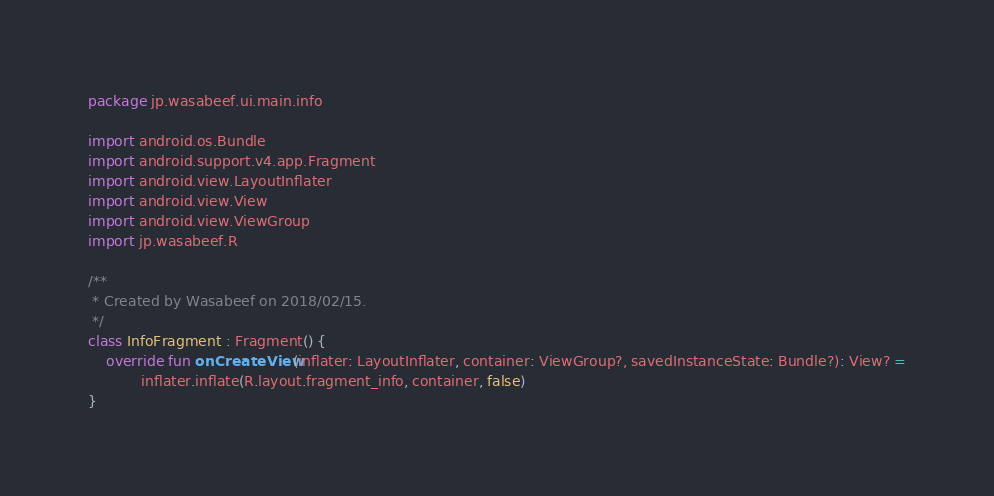<code> <loc_0><loc_0><loc_500><loc_500><_Kotlin_>package jp.wasabeef.ui.main.info

import android.os.Bundle
import android.support.v4.app.Fragment
import android.view.LayoutInflater
import android.view.View
import android.view.ViewGroup
import jp.wasabeef.R

/**
 * Created by Wasabeef on 2018/02/15.
 */
class InfoFragment : Fragment() {
    override fun onCreateView(inflater: LayoutInflater, container: ViewGroup?, savedInstanceState: Bundle?): View? =
            inflater.inflate(R.layout.fragment_info, container, false)
}
</code> 